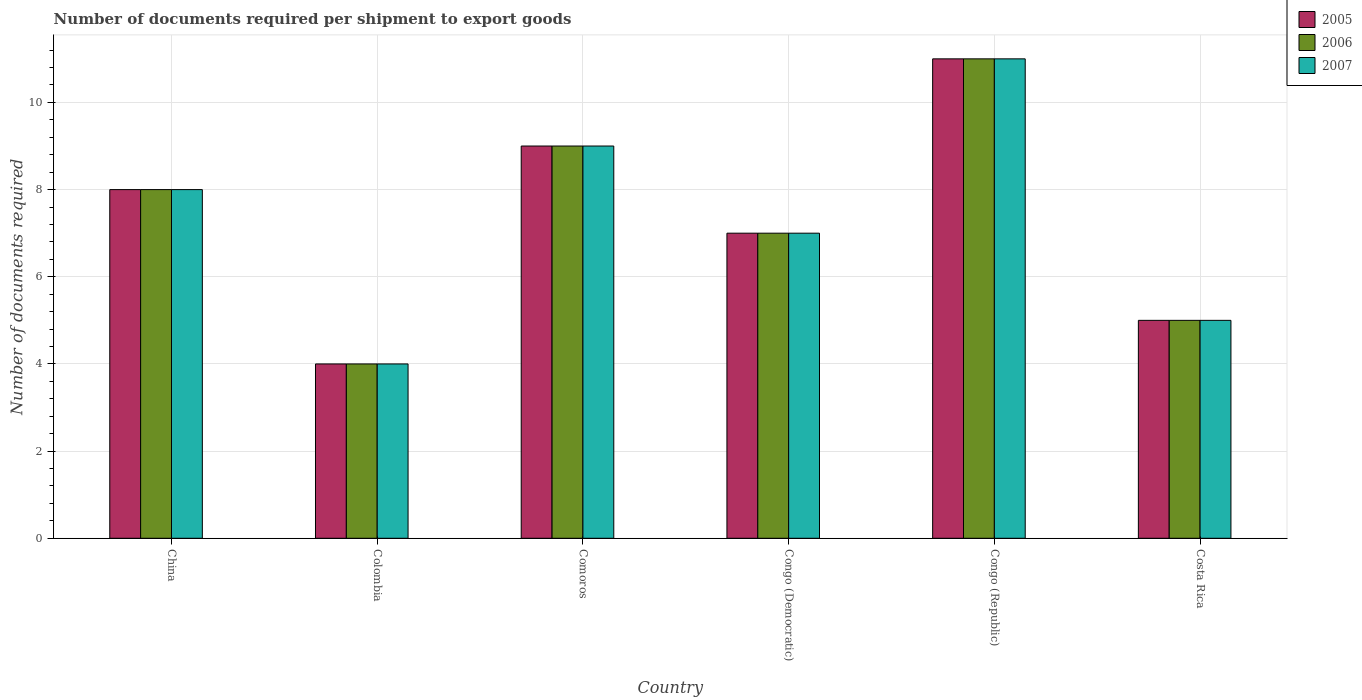How many groups of bars are there?
Your answer should be compact. 6. What is the label of the 3rd group of bars from the left?
Offer a terse response. Comoros. In how many cases, is the number of bars for a given country not equal to the number of legend labels?
Offer a very short reply. 0. What is the number of documents required per shipment to export goods in 2006 in China?
Provide a succinct answer. 8. Across all countries, what is the maximum number of documents required per shipment to export goods in 2007?
Give a very brief answer. 11. Across all countries, what is the minimum number of documents required per shipment to export goods in 2005?
Your answer should be compact. 4. In which country was the number of documents required per shipment to export goods in 2007 maximum?
Give a very brief answer. Congo (Republic). In which country was the number of documents required per shipment to export goods in 2006 minimum?
Give a very brief answer. Colombia. What is the average number of documents required per shipment to export goods in 2005 per country?
Provide a short and direct response. 7.33. What is the ratio of the number of documents required per shipment to export goods in 2007 in Comoros to that in Congo (Republic)?
Provide a short and direct response. 0.82. Is the number of documents required per shipment to export goods in 2005 in Colombia less than that in Congo (Republic)?
Make the answer very short. Yes. Is the difference between the number of documents required per shipment to export goods in 2005 in China and Comoros greater than the difference between the number of documents required per shipment to export goods in 2007 in China and Comoros?
Offer a terse response. No. What is the difference between the highest and the lowest number of documents required per shipment to export goods in 2006?
Provide a succinct answer. 7. In how many countries, is the number of documents required per shipment to export goods in 2007 greater than the average number of documents required per shipment to export goods in 2007 taken over all countries?
Offer a terse response. 3. Is the sum of the number of documents required per shipment to export goods in 2007 in Comoros and Congo (Democratic) greater than the maximum number of documents required per shipment to export goods in 2005 across all countries?
Your answer should be very brief. Yes. What does the 1st bar from the left in Colombia represents?
Ensure brevity in your answer.  2005. What does the 2nd bar from the right in Comoros represents?
Your answer should be compact. 2006. How many bars are there?
Provide a short and direct response. 18. Does the graph contain any zero values?
Your response must be concise. No. Where does the legend appear in the graph?
Provide a succinct answer. Top right. How are the legend labels stacked?
Make the answer very short. Vertical. What is the title of the graph?
Ensure brevity in your answer.  Number of documents required per shipment to export goods. What is the label or title of the X-axis?
Your answer should be very brief. Country. What is the label or title of the Y-axis?
Your response must be concise. Number of documents required. What is the Number of documents required in 2005 in China?
Make the answer very short. 8. What is the Number of documents required in 2007 in China?
Make the answer very short. 8. What is the Number of documents required in 2005 in Colombia?
Ensure brevity in your answer.  4. What is the Number of documents required of 2006 in Colombia?
Ensure brevity in your answer.  4. What is the Number of documents required of 2007 in Colombia?
Your response must be concise. 4. What is the Number of documents required in 2006 in Comoros?
Keep it short and to the point. 9. What is the Number of documents required in 2007 in Comoros?
Your answer should be very brief. 9. What is the Number of documents required in 2005 in Congo (Democratic)?
Provide a short and direct response. 7. What is the Number of documents required of 2007 in Congo (Democratic)?
Provide a succinct answer. 7. What is the Number of documents required in 2007 in Congo (Republic)?
Your response must be concise. 11. What is the Number of documents required of 2005 in Costa Rica?
Offer a terse response. 5. What is the Number of documents required of 2006 in Costa Rica?
Offer a very short reply. 5. Across all countries, what is the maximum Number of documents required in 2005?
Provide a succinct answer. 11. Across all countries, what is the maximum Number of documents required of 2007?
Your answer should be compact. 11. Across all countries, what is the minimum Number of documents required in 2005?
Offer a terse response. 4. Across all countries, what is the minimum Number of documents required of 2007?
Make the answer very short. 4. What is the total Number of documents required in 2006 in the graph?
Your answer should be compact. 44. What is the difference between the Number of documents required of 2006 in China and that in Colombia?
Your answer should be very brief. 4. What is the difference between the Number of documents required of 2007 in China and that in Colombia?
Offer a terse response. 4. What is the difference between the Number of documents required in 2005 in China and that in Comoros?
Offer a very short reply. -1. What is the difference between the Number of documents required in 2006 in China and that in Comoros?
Your answer should be very brief. -1. What is the difference between the Number of documents required of 2005 in China and that in Congo (Republic)?
Your answer should be compact. -3. What is the difference between the Number of documents required in 2006 in China and that in Congo (Republic)?
Keep it short and to the point. -3. What is the difference between the Number of documents required in 2007 in China and that in Congo (Republic)?
Offer a terse response. -3. What is the difference between the Number of documents required of 2006 in China and that in Costa Rica?
Ensure brevity in your answer.  3. What is the difference between the Number of documents required in 2005 in Colombia and that in Congo (Democratic)?
Provide a succinct answer. -3. What is the difference between the Number of documents required in 2007 in Colombia and that in Congo (Democratic)?
Offer a terse response. -3. What is the difference between the Number of documents required in 2005 in Colombia and that in Congo (Republic)?
Provide a succinct answer. -7. What is the difference between the Number of documents required in 2007 in Colombia and that in Congo (Republic)?
Provide a succinct answer. -7. What is the difference between the Number of documents required in 2006 in Colombia and that in Costa Rica?
Ensure brevity in your answer.  -1. What is the difference between the Number of documents required in 2007 in Colombia and that in Costa Rica?
Keep it short and to the point. -1. What is the difference between the Number of documents required of 2005 in Comoros and that in Congo (Democratic)?
Give a very brief answer. 2. What is the difference between the Number of documents required in 2006 in Comoros and that in Congo (Democratic)?
Your answer should be very brief. 2. What is the difference between the Number of documents required in 2006 in Comoros and that in Congo (Republic)?
Your answer should be very brief. -2. What is the difference between the Number of documents required in 2007 in Comoros and that in Congo (Republic)?
Keep it short and to the point. -2. What is the difference between the Number of documents required in 2005 in Comoros and that in Costa Rica?
Ensure brevity in your answer.  4. What is the difference between the Number of documents required in 2006 in Comoros and that in Costa Rica?
Your answer should be very brief. 4. What is the difference between the Number of documents required in 2005 in Congo (Democratic) and that in Congo (Republic)?
Your answer should be compact. -4. What is the difference between the Number of documents required of 2006 in Congo (Democratic) and that in Congo (Republic)?
Your response must be concise. -4. What is the difference between the Number of documents required in 2007 in Congo (Democratic) and that in Congo (Republic)?
Offer a very short reply. -4. What is the difference between the Number of documents required of 2005 in Congo (Republic) and that in Costa Rica?
Ensure brevity in your answer.  6. What is the difference between the Number of documents required in 2006 in Congo (Republic) and that in Costa Rica?
Offer a very short reply. 6. What is the difference between the Number of documents required in 2005 in China and the Number of documents required in 2006 in Colombia?
Provide a short and direct response. 4. What is the difference between the Number of documents required of 2005 in China and the Number of documents required of 2007 in Colombia?
Give a very brief answer. 4. What is the difference between the Number of documents required in 2005 in China and the Number of documents required in 2007 in Comoros?
Offer a terse response. -1. What is the difference between the Number of documents required of 2005 in China and the Number of documents required of 2007 in Congo (Democratic)?
Give a very brief answer. 1. What is the difference between the Number of documents required in 2005 in China and the Number of documents required in 2007 in Congo (Republic)?
Make the answer very short. -3. What is the difference between the Number of documents required of 2006 in China and the Number of documents required of 2007 in Congo (Republic)?
Your answer should be very brief. -3. What is the difference between the Number of documents required of 2005 in China and the Number of documents required of 2006 in Costa Rica?
Make the answer very short. 3. What is the difference between the Number of documents required in 2005 in China and the Number of documents required in 2007 in Costa Rica?
Offer a very short reply. 3. What is the difference between the Number of documents required in 2006 in China and the Number of documents required in 2007 in Costa Rica?
Ensure brevity in your answer.  3. What is the difference between the Number of documents required in 2005 in Colombia and the Number of documents required in 2006 in Comoros?
Offer a terse response. -5. What is the difference between the Number of documents required of 2005 in Colombia and the Number of documents required of 2007 in Comoros?
Provide a succinct answer. -5. What is the difference between the Number of documents required in 2006 in Colombia and the Number of documents required in 2007 in Comoros?
Your response must be concise. -5. What is the difference between the Number of documents required in 2005 in Colombia and the Number of documents required in 2007 in Congo (Democratic)?
Provide a short and direct response. -3. What is the difference between the Number of documents required of 2006 in Colombia and the Number of documents required of 2007 in Congo (Republic)?
Make the answer very short. -7. What is the difference between the Number of documents required in 2005 in Colombia and the Number of documents required in 2006 in Costa Rica?
Provide a succinct answer. -1. What is the difference between the Number of documents required in 2005 in Colombia and the Number of documents required in 2007 in Costa Rica?
Ensure brevity in your answer.  -1. What is the difference between the Number of documents required of 2005 in Comoros and the Number of documents required of 2007 in Congo (Democratic)?
Provide a succinct answer. 2. What is the difference between the Number of documents required of 2005 in Comoros and the Number of documents required of 2006 in Costa Rica?
Make the answer very short. 4. What is the difference between the Number of documents required of 2005 in Comoros and the Number of documents required of 2007 in Costa Rica?
Provide a succinct answer. 4. What is the difference between the Number of documents required of 2005 in Congo (Democratic) and the Number of documents required of 2006 in Congo (Republic)?
Offer a very short reply. -4. What is the difference between the Number of documents required of 2005 in Congo (Democratic) and the Number of documents required of 2006 in Costa Rica?
Your response must be concise. 2. What is the difference between the Number of documents required of 2005 in Congo (Democratic) and the Number of documents required of 2007 in Costa Rica?
Make the answer very short. 2. What is the difference between the Number of documents required in 2006 in Congo (Democratic) and the Number of documents required in 2007 in Costa Rica?
Your response must be concise. 2. What is the difference between the Number of documents required in 2005 in Congo (Republic) and the Number of documents required in 2007 in Costa Rica?
Your response must be concise. 6. What is the difference between the Number of documents required of 2006 in Congo (Republic) and the Number of documents required of 2007 in Costa Rica?
Your response must be concise. 6. What is the average Number of documents required in 2005 per country?
Make the answer very short. 7.33. What is the average Number of documents required in 2006 per country?
Offer a very short reply. 7.33. What is the average Number of documents required of 2007 per country?
Offer a very short reply. 7.33. What is the difference between the Number of documents required of 2006 and Number of documents required of 2007 in China?
Your answer should be very brief. 0. What is the difference between the Number of documents required in 2005 and Number of documents required in 2006 in Colombia?
Your response must be concise. 0. What is the difference between the Number of documents required of 2005 and Number of documents required of 2007 in Colombia?
Make the answer very short. 0. What is the difference between the Number of documents required in 2006 and Number of documents required in 2007 in Colombia?
Your answer should be compact. 0. What is the difference between the Number of documents required in 2005 and Number of documents required in 2006 in Costa Rica?
Provide a short and direct response. 0. What is the difference between the Number of documents required of 2006 and Number of documents required of 2007 in Costa Rica?
Give a very brief answer. 0. What is the ratio of the Number of documents required in 2005 in China to that in Colombia?
Your answer should be very brief. 2. What is the ratio of the Number of documents required in 2006 in China to that in Colombia?
Provide a short and direct response. 2. What is the ratio of the Number of documents required in 2007 in China to that in Colombia?
Provide a short and direct response. 2. What is the ratio of the Number of documents required in 2007 in China to that in Comoros?
Your response must be concise. 0.89. What is the ratio of the Number of documents required of 2005 in China to that in Congo (Democratic)?
Your answer should be very brief. 1.14. What is the ratio of the Number of documents required in 2005 in China to that in Congo (Republic)?
Provide a succinct answer. 0.73. What is the ratio of the Number of documents required of 2006 in China to that in Congo (Republic)?
Give a very brief answer. 0.73. What is the ratio of the Number of documents required in 2007 in China to that in Congo (Republic)?
Offer a terse response. 0.73. What is the ratio of the Number of documents required in 2005 in China to that in Costa Rica?
Offer a terse response. 1.6. What is the ratio of the Number of documents required in 2007 in China to that in Costa Rica?
Ensure brevity in your answer.  1.6. What is the ratio of the Number of documents required of 2005 in Colombia to that in Comoros?
Offer a very short reply. 0.44. What is the ratio of the Number of documents required in 2006 in Colombia to that in Comoros?
Provide a short and direct response. 0.44. What is the ratio of the Number of documents required of 2007 in Colombia to that in Comoros?
Provide a succinct answer. 0.44. What is the ratio of the Number of documents required in 2006 in Colombia to that in Congo (Democratic)?
Provide a succinct answer. 0.57. What is the ratio of the Number of documents required of 2007 in Colombia to that in Congo (Democratic)?
Provide a succinct answer. 0.57. What is the ratio of the Number of documents required in 2005 in Colombia to that in Congo (Republic)?
Ensure brevity in your answer.  0.36. What is the ratio of the Number of documents required of 2006 in Colombia to that in Congo (Republic)?
Offer a very short reply. 0.36. What is the ratio of the Number of documents required of 2007 in Colombia to that in Congo (Republic)?
Ensure brevity in your answer.  0.36. What is the ratio of the Number of documents required in 2006 in Colombia to that in Costa Rica?
Make the answer very short. 0.8. What is the ratio of the Number of documents required of 2005 in Comoros to that in Congo (Democratic)?
Your answer should be compact. 1.29. What is the ratio of the Number of documents required of 2007 in Comoros to that in Congo (Democratic)?
Your answer should be very brief. 1.29. What is the ratio of the Number of documents required of 2005 in Comoros to that in Congo (Republic)?
Offer a very short reply. 0.82. What is the ratio of the Number of documents required of 2006 in Comoros to that in Congo (Republic)?
Provide a succinct answer. 0.82. What is the ratio of the Number of documents required of 2007 in Comoros to that in Congo (Republic)?
Provide a succinct answer. 0.82. What is the ratio of the Number of documents required of 2006 in Comoros to that in Costa Rica?
Your response must be concise. 1.8. What is the ratio of the Number of documents required in 2007 in Comoros to that in Costa Rica?
Make the answer very short. 1.8. What is the ratio of the Number of documents required in 2005 in Congo (Democratic) to that in Congo (Republic)?
Offer a terse response. 0.64. What is the ratio of the Number of documents required of 2006 in Congo (Democratic) to that in Congo (Republic)?
Your answer should be compact. 0.64. What is the ratio of the Number of documents required of 2007 in Congo (Democratic) to that in Congo (Republic)?
Offer a very short reply. 0.64. What is the ratio of the Number of documents required of 2006 in Congo (Democratic) to that in Costa Rica?
Make the answer very short. 1.4. What is the ratio of the Number of documents required of 2007 in Congo (Democratic) to that in Costa Rica?
Keep it short and to the point. 1.4. What is the ratio of the Number of documents required of 2005 in Congo (Republic) to that in Costa Rica?
Provide a short and direct response. 2.2. What is the difference between the highest and the second highest Number of documents required in 2005?
Offer a terse response. 2. What is the difference between the highest and the second highest Number of documents required of 2006?
Make the answer very short. 2. What is the difference between the highest and the second highest Number of documents required in 2007?
Give a very brief answer. 2. What is the difference between the highest and the lowest Number of documents required of 2005?
Give a very brief answer. 7. What is the difference between the highest and the lowest Number of documents required of 2006?
Offer a very short reply. 7. What is the difference between the highest and the lowest Number of documents required in 2007?
Make the answer very short. 7. 